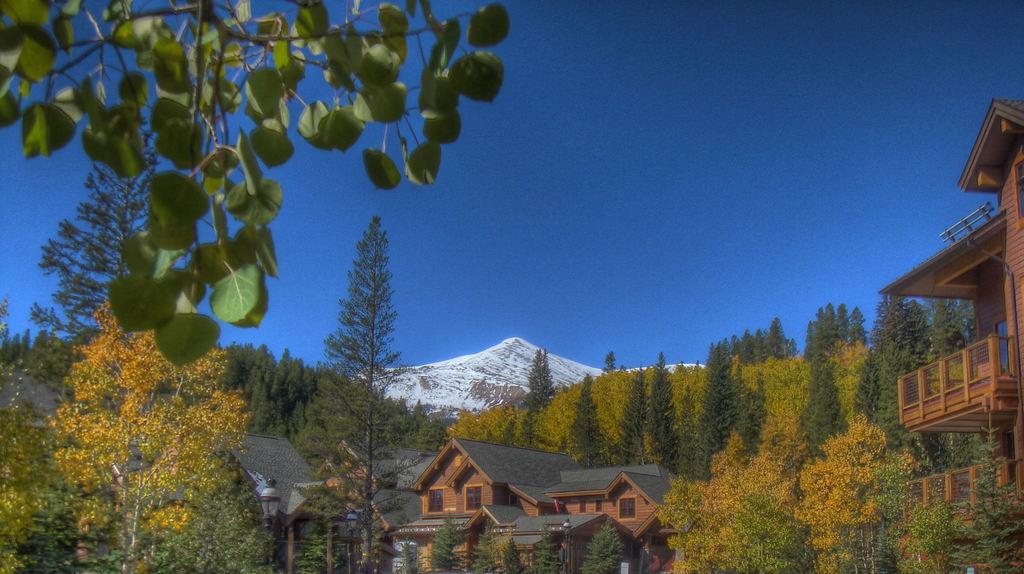What color is the sky in the image? The sky is blue in the image. What type of structures can be seen in the image? There are buildings in the image. What are the tall, vertical objects in the image? Light poles are present in the image. What type of vegetation is visible in the image? Trees are visible in the image. What can be seen in the distance in the image? There is a mountain in the background of the image. What type of street can be seen in the image? There is no street present in the image; it features a blue sky, buildings, light poles, trees, and a mountain in the background. 